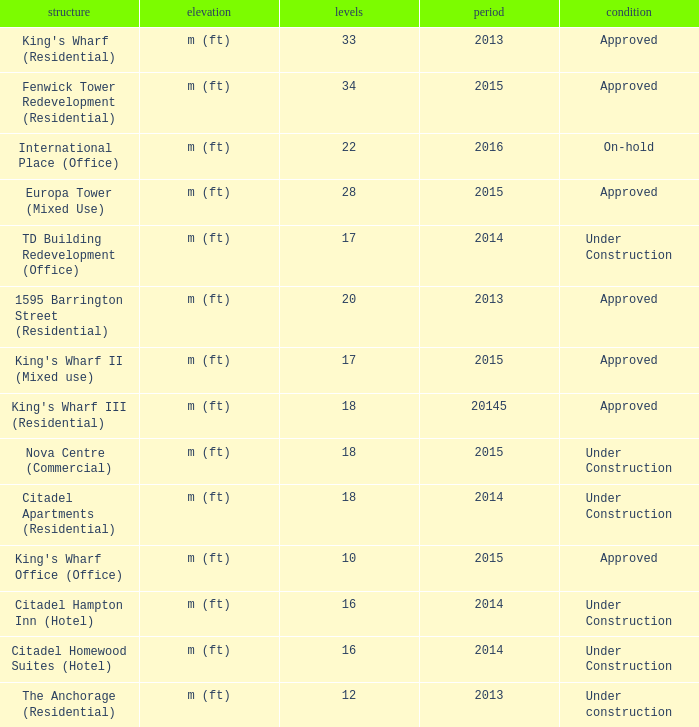What building shows 2013 and has more than 20 floors? King's Wharf (Residential). 